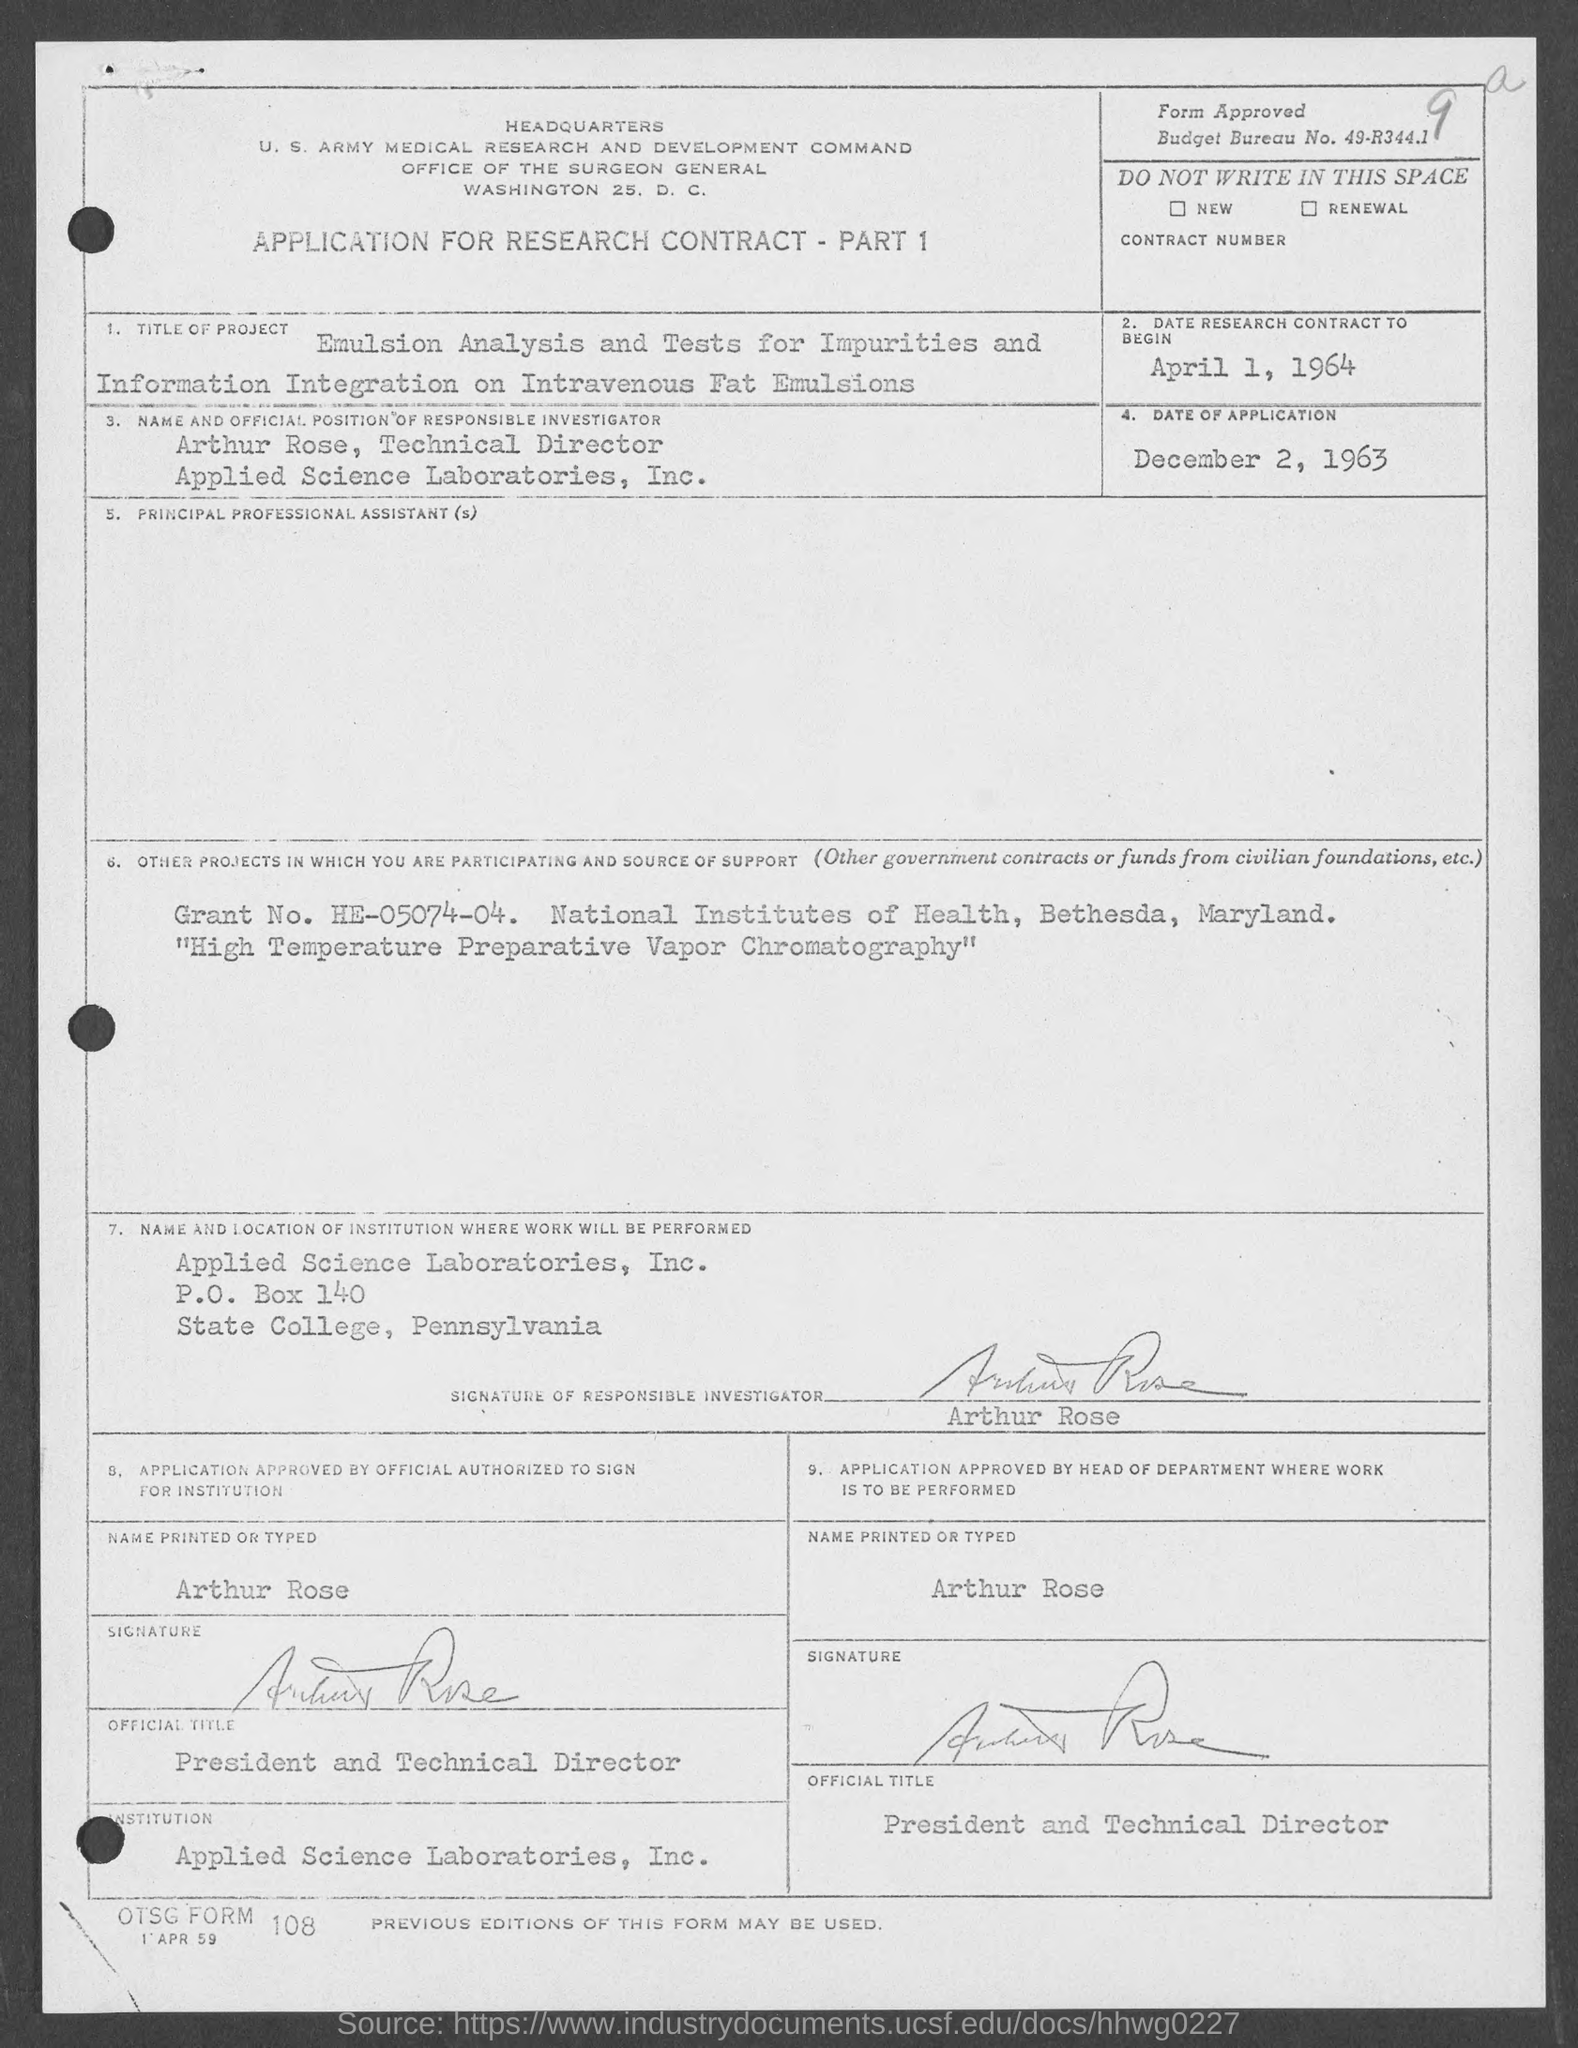Highlight a few significant elements in this photo. The date of application is December 2, 1963. The date of the research contract to begin is April 1, 1964. Applied Science Laboratories, Inc. is located in Pennsylvania. The P.O. Box number is 140. The grant number is HE-05074-04. 